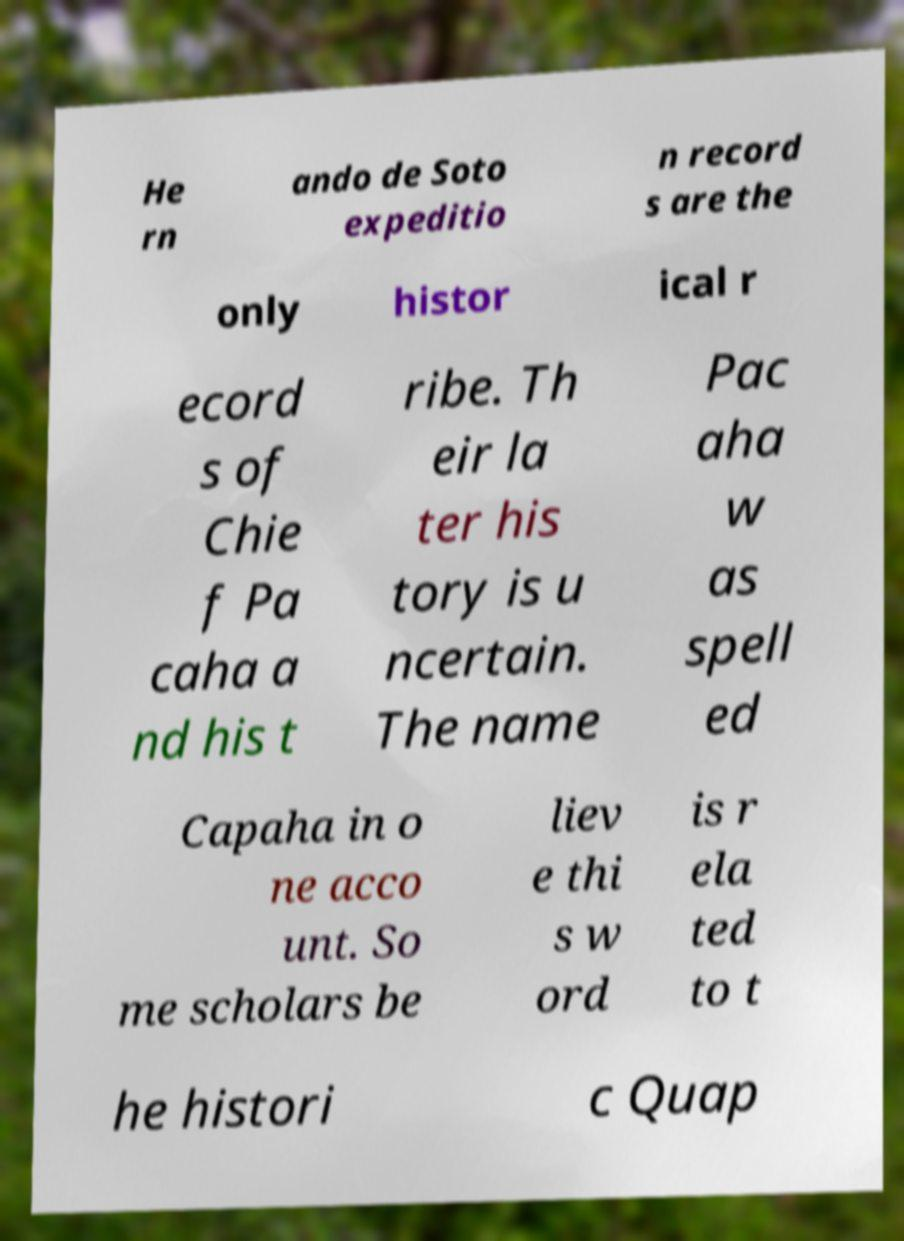Could you extract and type out the text from this image? He rn ando de Soto expeditio n record s are the only histor ical r ecord s of Chie f Pa caha a nd his t ribe. Th eir la ter his tory is u ncertain. The name Pac aha w as spell ed Capaha in o ne acco unt. So me scholars be liev e thi s w ord is r ela ted to t he histori c Quap 